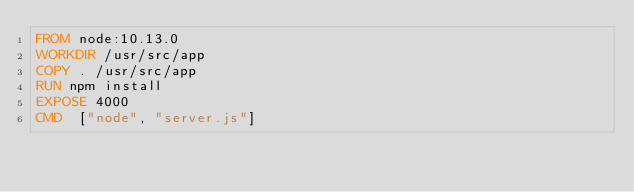Convert code to text. <code><loc_0><loc_0><loc_500><loc_500><_Dockerfile_>FROM node:10.13.0
WORKDIR /usr/src/app
COPY . /usr/src/app
RUN npm install
EXPOSE 4000
CMD  ["node", "server.js"]</code> 